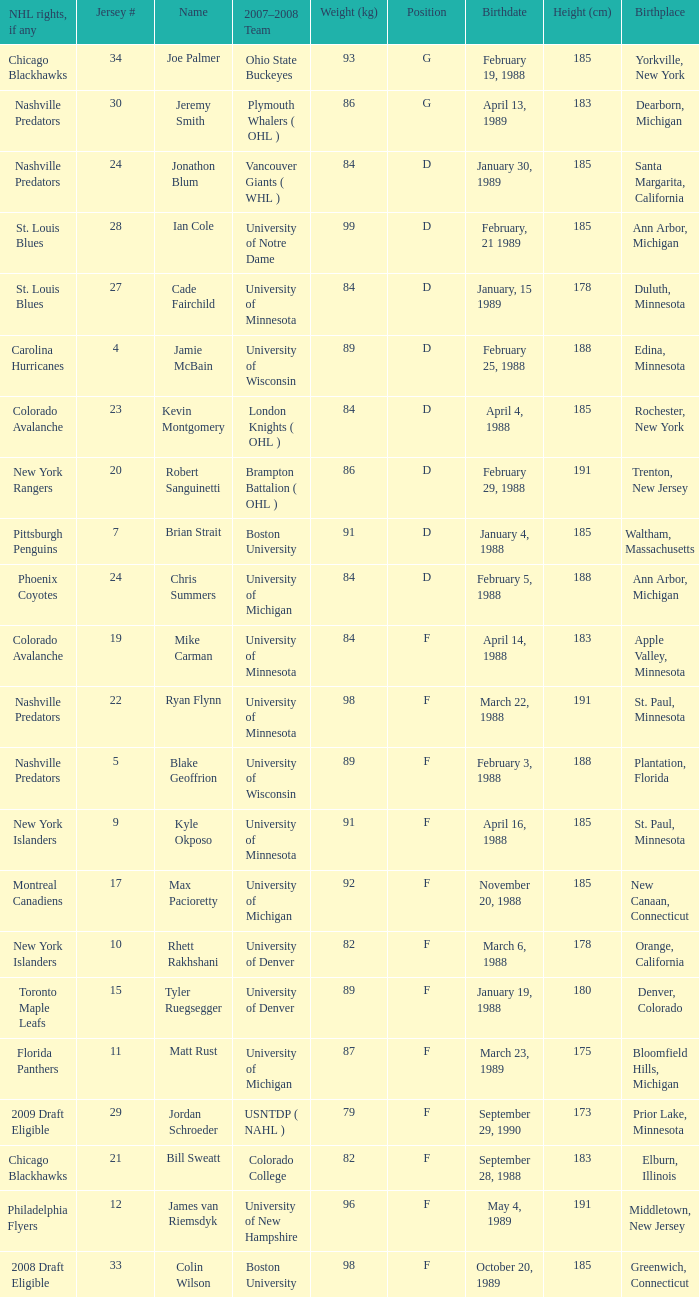Does a phoenix coyotes-affiliated nhl player have a specific weight (kg)? 1.0. 